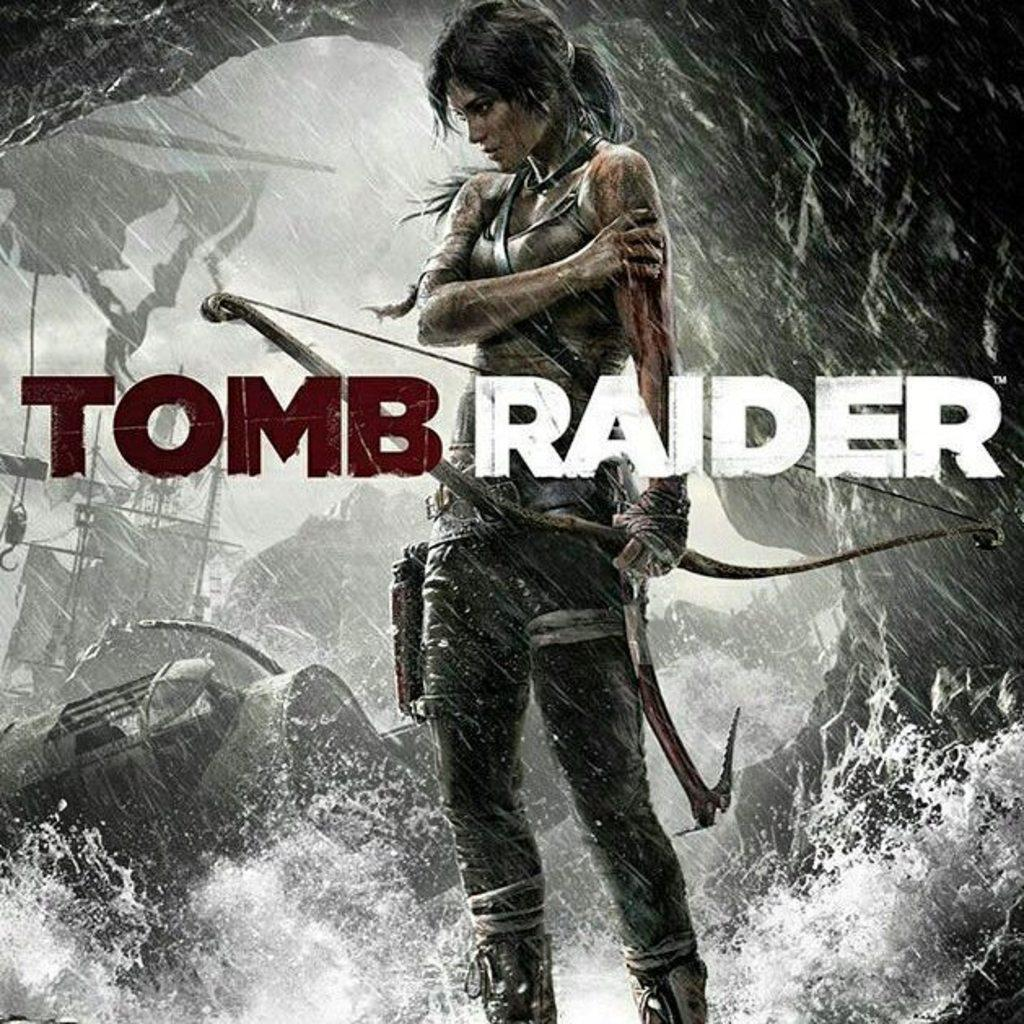<image>
Give a short and clear explanation of the subsequent image. A woman is standing in the rain with a bow in a Tomb Raider advertisement. 